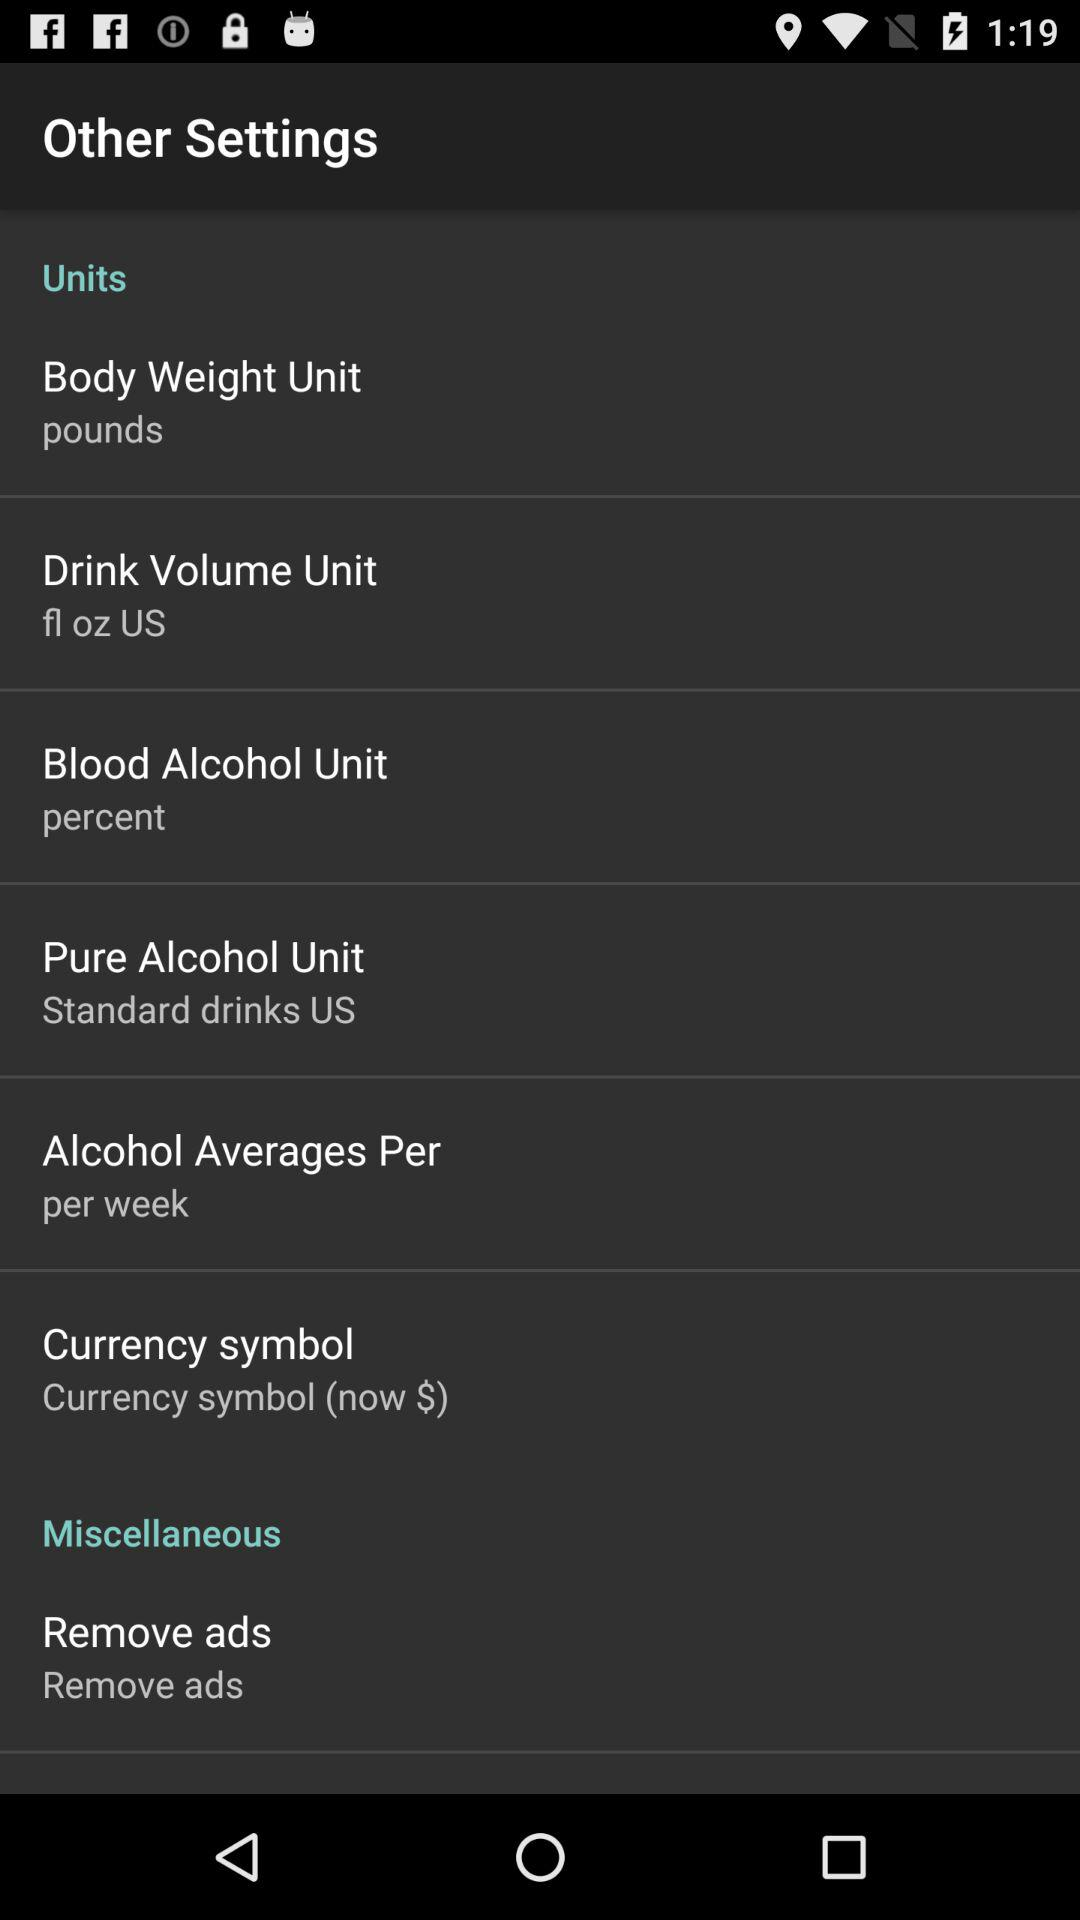What is the unit of body weight? The unit of body weight is pounds. 